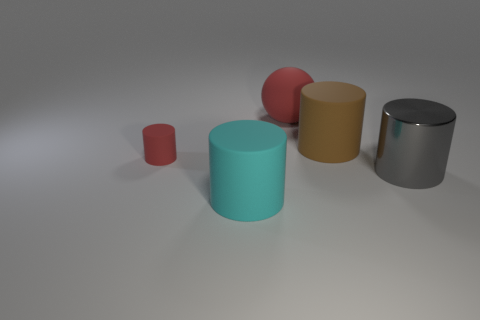Subtract all cyan cylinders. How many cylinders are left? 3 Add 1 tiny red cylinders. How many objects exist? 6 Subtract 1 cylinders. How many cylinders are left? 3 Subtract all brown cylinders. How many cylinders are left? 3 Subtract all cylinders. How many objects are left? 1 Subtract all red cylinders. Subtract all purple balls. How many cylinders are left? 3 Subtract all blue blocks. Subtract all large brown rubber things. How many objects are left? 4 Add 1 brown matte objects. How many brown matte objects are left? 2 Add 2 large shiny cylinders. How many large shiny cylinders exist? 3 Subtract 1 cyan cylinders. How many objects are left? 4 